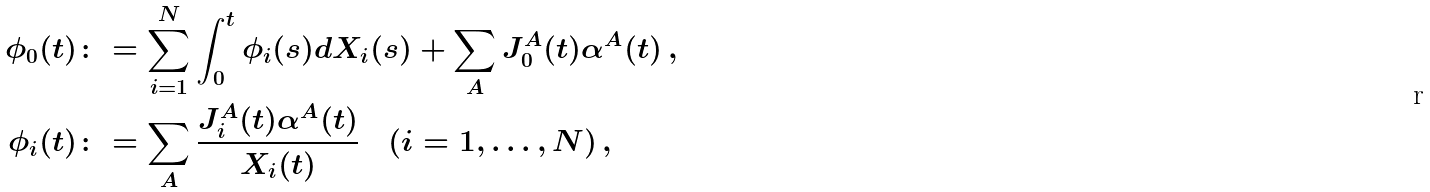Convert formula to latex. <formula><loc_0><loc_0><loc_500><loc_500>\phi _ { 0 } ( t ) & \colon = \sum _ { i = 1 } ^ { N } \int _ { 0 } ^ { t } \phi _ { i } ( s ) d X _ { i } ( s ) + \sum _ { A } J ^ { A } _ { 0 } ( t ) \alpha ^ { A } ( t ) \, , \\ \phi _ { i } ( t ) & \colon = \sum _ { A } \frac { J ^ { A } _ { i } ( t ) \alpha ^ { A } ( t ) } { X _ { i } ( t ) } \quad ( i = 1 , \dots , N ) \, ,</formula> 